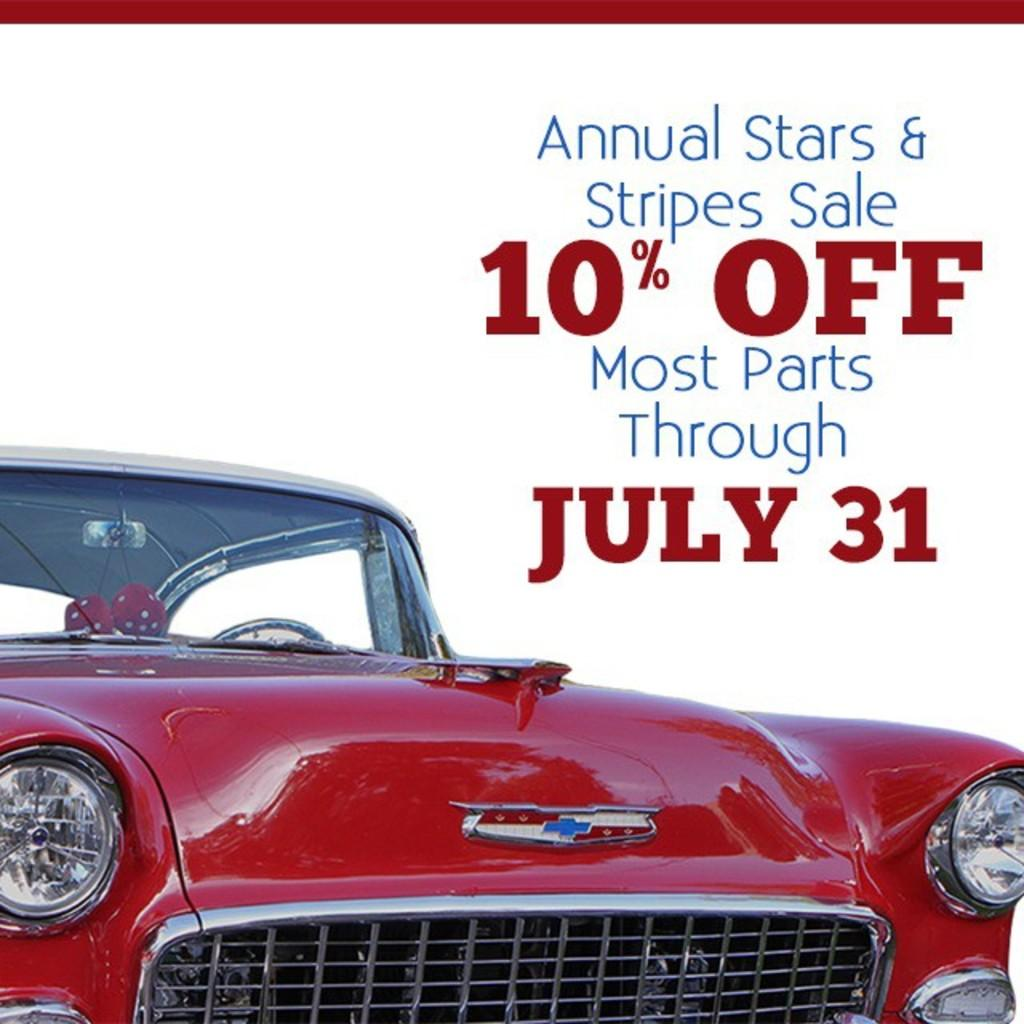What is featured on the poster in the image? There is a poster in the image, and text is written on it. Can you describe the car in the image? There is a red color car in the image, and it is truncated. What is the color of the background in the image? The background of the image is white. What type of rings can be seen on the car in the image? There are no rings present on the car in the image. What is the weight of the poster in the image? The weight of the poster cannot be determined from the image alone. 